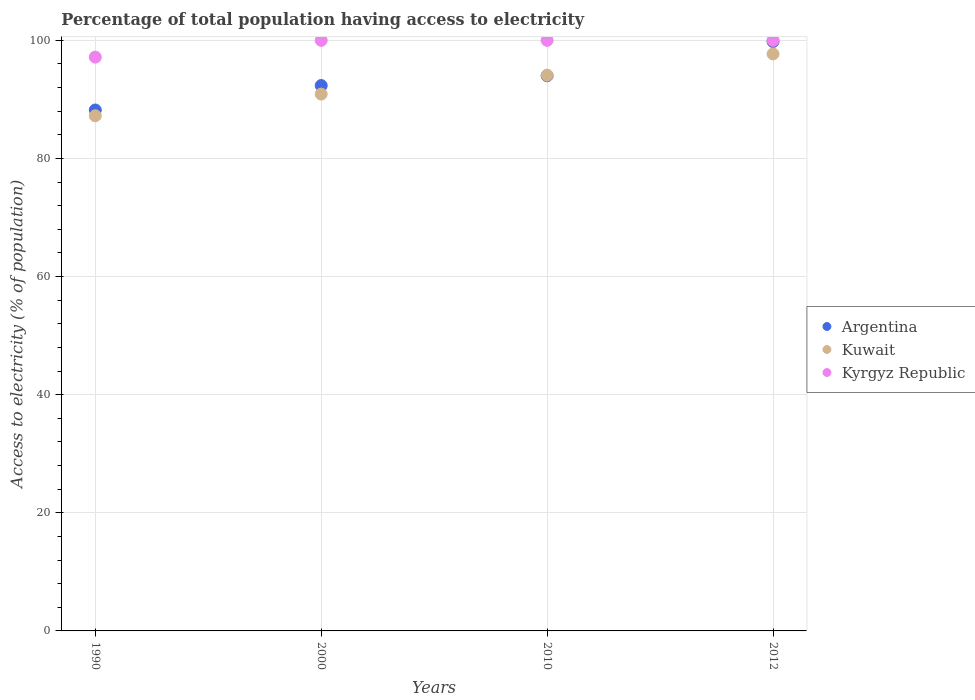Is the number of dotlines equal to the number of legend labels?
Your answer should be very brief. Yes. What is the percentage of population that have access to electricity in Kyrgyz Republic in 2012?
Your answer should be very brief. 100. Across all years, what is the maximum percentage of population that have access to electricity in Kuwait?
Provide a short and direct response. 97.7. Across all years, what is the minimum percentage of population that have access to electricity in Argentina?
Your response must be concise. 88.21. In which year was the percentage of population that have access to electricity in Kyrgyz Republic maximum?
Your response must be concise. 2000. What is the total percentage of population that have access to electricity in Kuwait in the graph?
Your answer should be very brief. 369.92. What is the difference between the percentage of population that have access to electricity in Argentina in 2000 and that in 2012?
Keep it short and to the point. -7.45. What is the difference between the percentage of population that have access to electricity in Kuwait in 2000 and the percentage of population that have access to electricity in Argentina in 2010?
Offer a terse response. -3.1. What is the average percentage of population that have access to electricity in Argentina per year?
Your response must be concise. 93.59. In how many years, is the percentage of population that have access to electricity in Kuwait greater than 76 %?
Make the answer very short. 4. What is the ratio of the percentage of population that have access to electricity in Argentina in 1990 to that in 2012?
Make the answer very short. 0.88. Is the percentage of population that have access to electricity in Kuwait in 2000 less than that in 2010?
Provide a succinct answer. Yes. Is the difference between the percentage of population that have access to electricity in Kyrgyz Republic in 2000 and 2010 greater than the difference between the percentage of population that have access to electricity in Argentina in 2000 and 2010?
Provide a short and direct response. Yes. What is the difference between the highest and the second highest percentage of population that have access to electricity in Kuwait?
Give a very brief answer. 3.6. What is the difference between the highest and the lowest percentage of population that have access to electricity in Argentina?
Offer a very short reply. 11.59. Does the percentage of population that have access to electricity in Argentina monotonically increase over the years?
Your answer should be very brief. Yes. Is the percentage of population that have access to electricity in Kuwait strictly greater than the percentage of population that have access to electricity in Argentina over the years?
Make the answer very short. No. Is the percentage of population that have access to electricity in Argentina strictly less than the percentage of population that have access to electricity in Kyrgyz Republic over the years?
Your response must be concise. Yes. How many years are there in the graph?
Keep it short and to the point. 4. What is the difference between two consecutive major ticks on the Y-axis?
Your answer should be very brief. 20. Does the graph contain grids?
Make the answer very short. Yes. How many legend labels are there?
Your answer should be very brief. 3. What is the title of the graph?
Ensure brevity in your answer.  Percentage of total population having access to electricity. Does "High income: OECD" appear as one of the legend labels in the graph?
Your response must be concise. No. What is the label or title of the X-axis?
Make the answer very short. Years. What is the label or title of the Y-axis?
Offer a terse response. Access to electricity (% of population). What is the Access to electricity (% of population) in Argentina in 1990?
Ensure brevity in your answer.  88.21. What is the Access to electricity (% of population) in Kuwait in 1990?
Your answer should be compact. 87.23. What is the Access to electricity (% of population) of Kyrgyz Republic in 1990?
Make the answer very short. 97.16. What is the Access to electricity (% of population) of Argentina in 2000?
Your answer should be compact. 92.35. What is the Access to electricity (% of population) of Kuwait in 2000?
Provide a succinct answer. 90.9. What is the Access to electricity (% of population) of Argentina in 2010?
Ensure brevity in your answer.  94. What is the Access to electricity (% of population) of Kuwait in 2010?
Offer a terse response. 94.1. What is the Access to electricity (% of population) in Kyrgyz Republic in 2010?
Your answer should be very brief. 100. What is the Access to electricity (% of population) of Argentina in 2012?
Offer a very short reply. 99.8. What is the Access to electricity (% of population) of Kuwait in 2012?
Offer a very short reply. 97.7. Across all years, what is the maximum Access to electricity (% of population) of Argentina?
Keep it short and to the point. 99.8. Across all years, what is the maximum Access to electricity (% of population) of Kuwait?
Keep it short and to the point. 97.7. Across all years, what is the minimum Access to electricity (% of population) in Argentina?
Your response must be concise. 88.21. Across all years, what is the minimum Access to electricity (% of population) in Kuwait?
Make the answer very short. 87.23. Across all years, what is the minimum Access to electricity (% of population) in Kyrgyz Republic?
Give a very brief answer. 97.16. What is the total Access to electricity (% of population) in Argentina in the graph?
Provide a short and direct response. 374.36. What is the total Access to electricity (% of population) of Kuwait in the graph?
Offer a terse response. 369.92. What is the total Access to electricity (% of population) in Kyrgyz Republic in the graph?
Provide a short and direct response. 397.16. What is the difference between the Access to electricity (% of population) of Argentina in 1990 and that in 2000?
Your answer should be compact. -4.14. What is the difference between the Access to electricity (% of population) of Kuwait in 1990 and that in 2000?
Offer a terse response. -3.67. What is the difference between the Access to electricity (% of population) of Kyrgyz Republic in 1990 and that in 2000?
Your answer should be compact. -2.84. What is the difference between the Access to electricity (% of population) in Argentina in 1990 and that in 2010?
Give a very brief answer. -5.79. What is the difference between the Access to electricity (% of population) of Kuwait in 1990 and that in 2010?
Provide a short and direct response. -6.87. What is the difference between the Access to electricity (% of population) of Kyrgyz Republic in 1990 and that in 2010?
Keep it short and to the point. -2.84. What is the difference between the Access to electricity (% of population) in Argentina in 1990 and that in 2012?
Offer a very short reply. -11.59. What is the difference between the Access to electricity (% of population) of Kuwait in 1990 and that in 2012?
Your response must be concise. -10.47. What is the difference between the Access to electricity (% of population) of Kyrgyz Republic in 1990 and that in 2012?
Your response must be concise. -2.84. What is the difference between the Access to electricity (% of population) of Argentina in 2000 and that in 2010?
Provide a short and direct response. -1.65. What is the difference between the Access to electricity (% of population) in Kuwait in 2000 and that in 2010?
Provide a succinct answer. -3.2. What is the difference between the Access to electricity (% of population) in Argentina in 2000 and that in 2012?
Give a very brief answer. -7.45. What is the difference between the Access to electricity (% of population) of Kuwait in 2000 and that in 2012?
Offer a very short reply. -6.8. What is the difference between the Access to electricity (% of population) of Kyrgyz Republic in 2000 and that in 2012?
Your response must be concise. 0. What is the difference between the Access to electricity (% of population) in Kuwait in 2010 and that in 2012?
Give a very brief answer. -3.6. What is the difference between the Access to electricity (% of population) of Kyrgyz Republic in 2010 and that in 2012?
Your answer should be compact. 0. What is the difference between the Access to electricity (% of population) of Argentina in 1990 and the Access to electricity (% of population) of Kuwait in 2000?
Your answer should be very brief. -2.69. What is the difference between the Access to electricity (% of population) in Argentina in 1990 and the Access to electricity (% of population) in Kyrgyz Republic in 2000?
Give a very brief answer. -11.79. What is the difference between the Access to electricity (% of population) in Kuwait in 1990 and the Access to electricity (% of population) in Kyrgyz Republic in 2000?
Make the answer very short. -12.77. What is the difference between the Access to electricity (% of population) of Argentina in 1990 and the Access to electricity (% of population) of Kuwait in 2010?
Provide a succinct answer. -5.89. What is the difference between the Access to electricity (% of population) of Argentina in 1990 and the Access to electricity (% of population) of Kyrgyz Republic in 2010?
Your answer should be very brief. -11.79. What is the difference between the Access to electricity (% of population) of Kuwait in 1990 and the Access to electricity (% of population) of Kyrgyz Republic in 2010?
Offer a terse response. -12.77. What is the difference between the Access to electricity (% of population) in Argentina in 1990 and the Access to electricity (% of population) in Kuwait in 2012?
Keep it short and to the point. -9.49. What is the difference between the Access to electricity (% of population) of Argentina in 1990 and the Access to electricity (% of population) of Kyrgyz Republic in 2012?
Provide a short and direct response. -11.79. What is the difference between the Access to electricity (% of population) of Kuwait in 1990 and the Access to electricity (% of population) of Kyrgyz Republic in 2012?
Your answer should be very brief. -12.77. What is the difference between the Access to electricity (% of population) of Argentina in 2000 and the Access to electricity (% of population) of Kuwait in 2010?
Make the answer very short. -1.75. What is the difference between the Access to electricity (% of population) in Argentina in 2000 and the Access to electricity (% of population) in Kyrgyz Republic in 2010?
Make the answer very short. -7.65. What is the difference between the Access to electricity (% of population) of Kuwait in 2000 and the Access to electricity (% of population) of Kyrgyz Republic in 2010?
Provide a short and direct response. -9.1. What is the difference between the Access to electricity (% of population) of Argentina in 2000 and the Access to electricity (% of population) of Kuwait in 2012?
Provide a succinct answer. -5.35. What is the difference between the Access to electricity (% of population) in Argentina in 2000 and the Access to electricity (% of population) in Kyrgyz Republic in 2012?
Your answer should be very brief. -7.65. What is the difference between the Access to electricity (% of population) in Kuwait in 2000 and the Access to electricity (% of population) in Kyrgyz Republic in 2012?
Keep it short and to the point. -9.1. What is the difference between the Access to electricity (% of population) in Argentina in 2010 and the Access to electricity (% of population) in Kuwait in 2012?
Provide a succinct answer. -3.7. What is the difference between the Access to electricity (% of population) in Argentina in 2010 and the Access to electricity (% of population) in Kyrgyz Republic in 2012?
Ensure brevity in your answer.  -6. What is the difference between the Access to electricity (% of population) in Kuwait in 2010 and the Access to electricity (% of population) in Kyrgyz Republic in 2012?
Provide a succinct answer. -5.9. What is the average Access to electricity (% of population) of Argentina per year?
Ensure brevity in your answer.  93.59. What is the average Access to electricity (% of population) in Kuwait per year?
Your answer should be compact. 92.48. What is the average Access to electricity (% of population) of Kyrgyz Republic per year?
Your response must be concise. 99.29. In the year 1990, what is the difference between the Access to electricity (% of population) of Argentina and Access to electricity (% of population) of Kuwait?
Make the answer very short. 0.98. In the year 1990, what is the difference between the Access to electricity (% of population) of Argentina and Access to electricity (% of population) of Kyrgyz Republic?
Your answer should be very brief. -8.95. In the year 1990, what is the difference between the Access to electricity (% of population) of Kuwait and Access to electricity (% of population) of Kyrgyz Republic?
Make the answer very short. -9.93. In the year 2000, what is the difference between the Access to electricity (% of population) of Argentina and Access to electricity (% of population) of Kuwait?
Give a very brief answer. 1.45. In the year 2000, what is the difference between the Access to electricity (% of population) in Argentina and Access to electricity (% of population) in Kyrgyz Republic?
Your response must be concise. -7.65. In the year 2000, what is the difference between the Access to electricity (% of population) in Kuwait and Access to electricity (% of population) in Kyrgyz Republic?
Offer a very short reply. -9.1. In the year 2010, what is the difference between the Access to electricity (% of population) in Argentina and Access to electricity (% of population) in Kuwait?
Offer a very short reply. -0.1. In the year 2012, what is the difference between the Access to electricity (% of population) of Argentina and Access to electricity (% of population) of Kuwait?
Your answer should be compact. 2.1. In the year 2012, what is the difference between the Access to electricity (% of population) in Kuwait and Access to electricity (% of population) in Kyrgyz Republic?
Provide a succinct answer. -2.3. What is the ratio of the Access to electricity (% of population) of Argentina in 1990 to that in 2000?
Make the answer very short. 0.96. What is the ratio of the Access to electricity (% of population) of Kuwait in 1990 to that in 2000?
Give a very brief answer. 0.96. What is the ratio of the Access to electricity (% of population) of Kyrgyz Republic in 1990 to that in 2000?
Give a very brief answer. 0.97. What is the ratio of the Access to electricity (% of population) in Argentina in 1990 to that in 2010?
Offer a terse response. 0.94. What is the ratio of the Access to electricity (% of population) of Kuwait in 1990 to that in 2010?
Make the answer very short. 0.93. What is the ratio of the Access to electricity (% of population) in Kyrgyz Republic in 1990 to that in 2010?
Your answer should be compact. 0.97. What is the ratio of the Access to electricity (% of population) in Argentina in 1990 to that in 2012?
Your answer should be very brief. 0.88. What is the ratio of the Access to electricity (% of population) in Kuwait in 1990 to that in 2012?
Keep it short and to the point. 0.89. What is the ratio of the Access to electricity (% of population) of Kyrgyz Republic in 1990 to that in 2012?
Offer a terse response. 0.97. What is the ratio of the Access to electricity (% of population) in Argentina in 2000 to that in 2010?
Ensure brevity in your answer.  0.98. What is the ratio of the Access to electricity (% of population) in Kuwait in 2000 to that in 2010?
Ensure brevity in your answer.  0.97. What is the ratio of the Access to electricity (% of population) in Argentina in 2000 to that in 2012?
Offer a terse response. 0.93. What is the ratio of the Access to electricity (% of population) of Kuwait in 2000 to that in 2012?
Ensure brevity in your answer.  0.93. What is the ratio of the Access to electricity (% of population) of Argentina in 2010 to that in 2012?
Keep it short and to the point. 0.94. What is the ratio of the Access to electricity (% of population) in Kuwait in 2010 to that in 2012?
Ensure brevity in your answer.  0.96. What is the ratio of the Access to electricity (% of population) of Kyrgyz Republic in 2010 to that in 2012?
Provide a succinct answer. 1. What is the difference between the highest and the second highest Access to electricity (% of population) of Kuwait?
Provide a short and direct response. 3.6. What is the difference between the highest and the lowest Access to electricity (% of population) of Argentina?
Offer a very short reply. 11.59. What is the difference between the highest and the lowest Access to electricity (% of population) of Kuwait?
Your answer should be compact. 10.47. What is the difference between the highest and the lowest Access to electricity (% of population) in Kyrgyz Republic?
Ensure brevity in your answer.  2.84. 